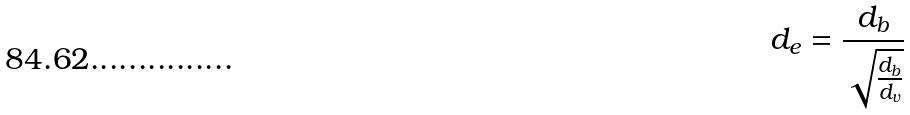Convert formula to latex. <formula><loc_0><loc_0><loc_500><loc_500>d _ { e } = \frac { d _ { b } } { \sqrt { \frac { d _ { b } } { d _ { v } } } }</formula> 